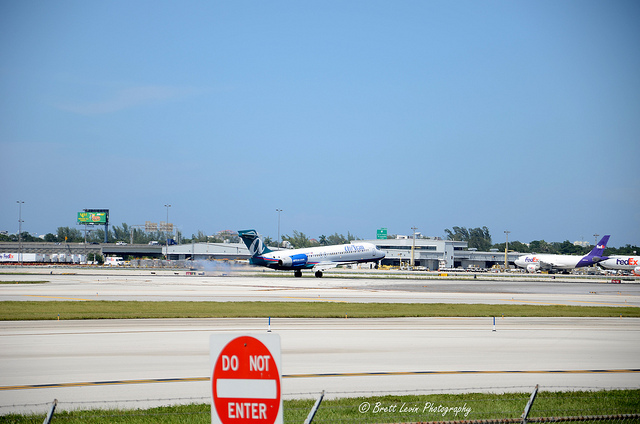Is there any signage or indications that would provide safety information to individuals at this site? Yes, there is a prominent red and white 'DO NOT ENTER' sign in the foreground, which is a critical safety message at airports. Such signs are commonly placed near runways and taxiways to prevent unauthorized vehicles and personnel from entering areas where aircraft are active, to ensure safety and avoid accidents on the ground. 